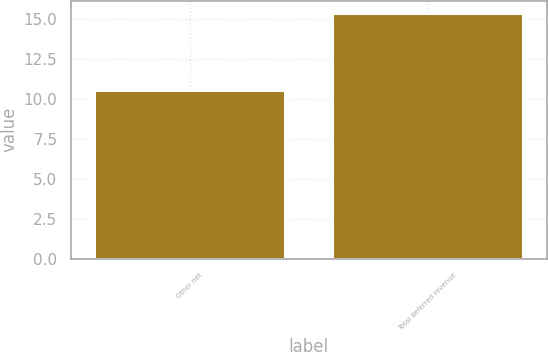<chart> <loc_0><loc_0><loc_500><loc_500><bar_chart><fcel>Other net<fcel>Total deferred revenue<nl><fcel>10.6<fcel>15.4<nl></chart> 